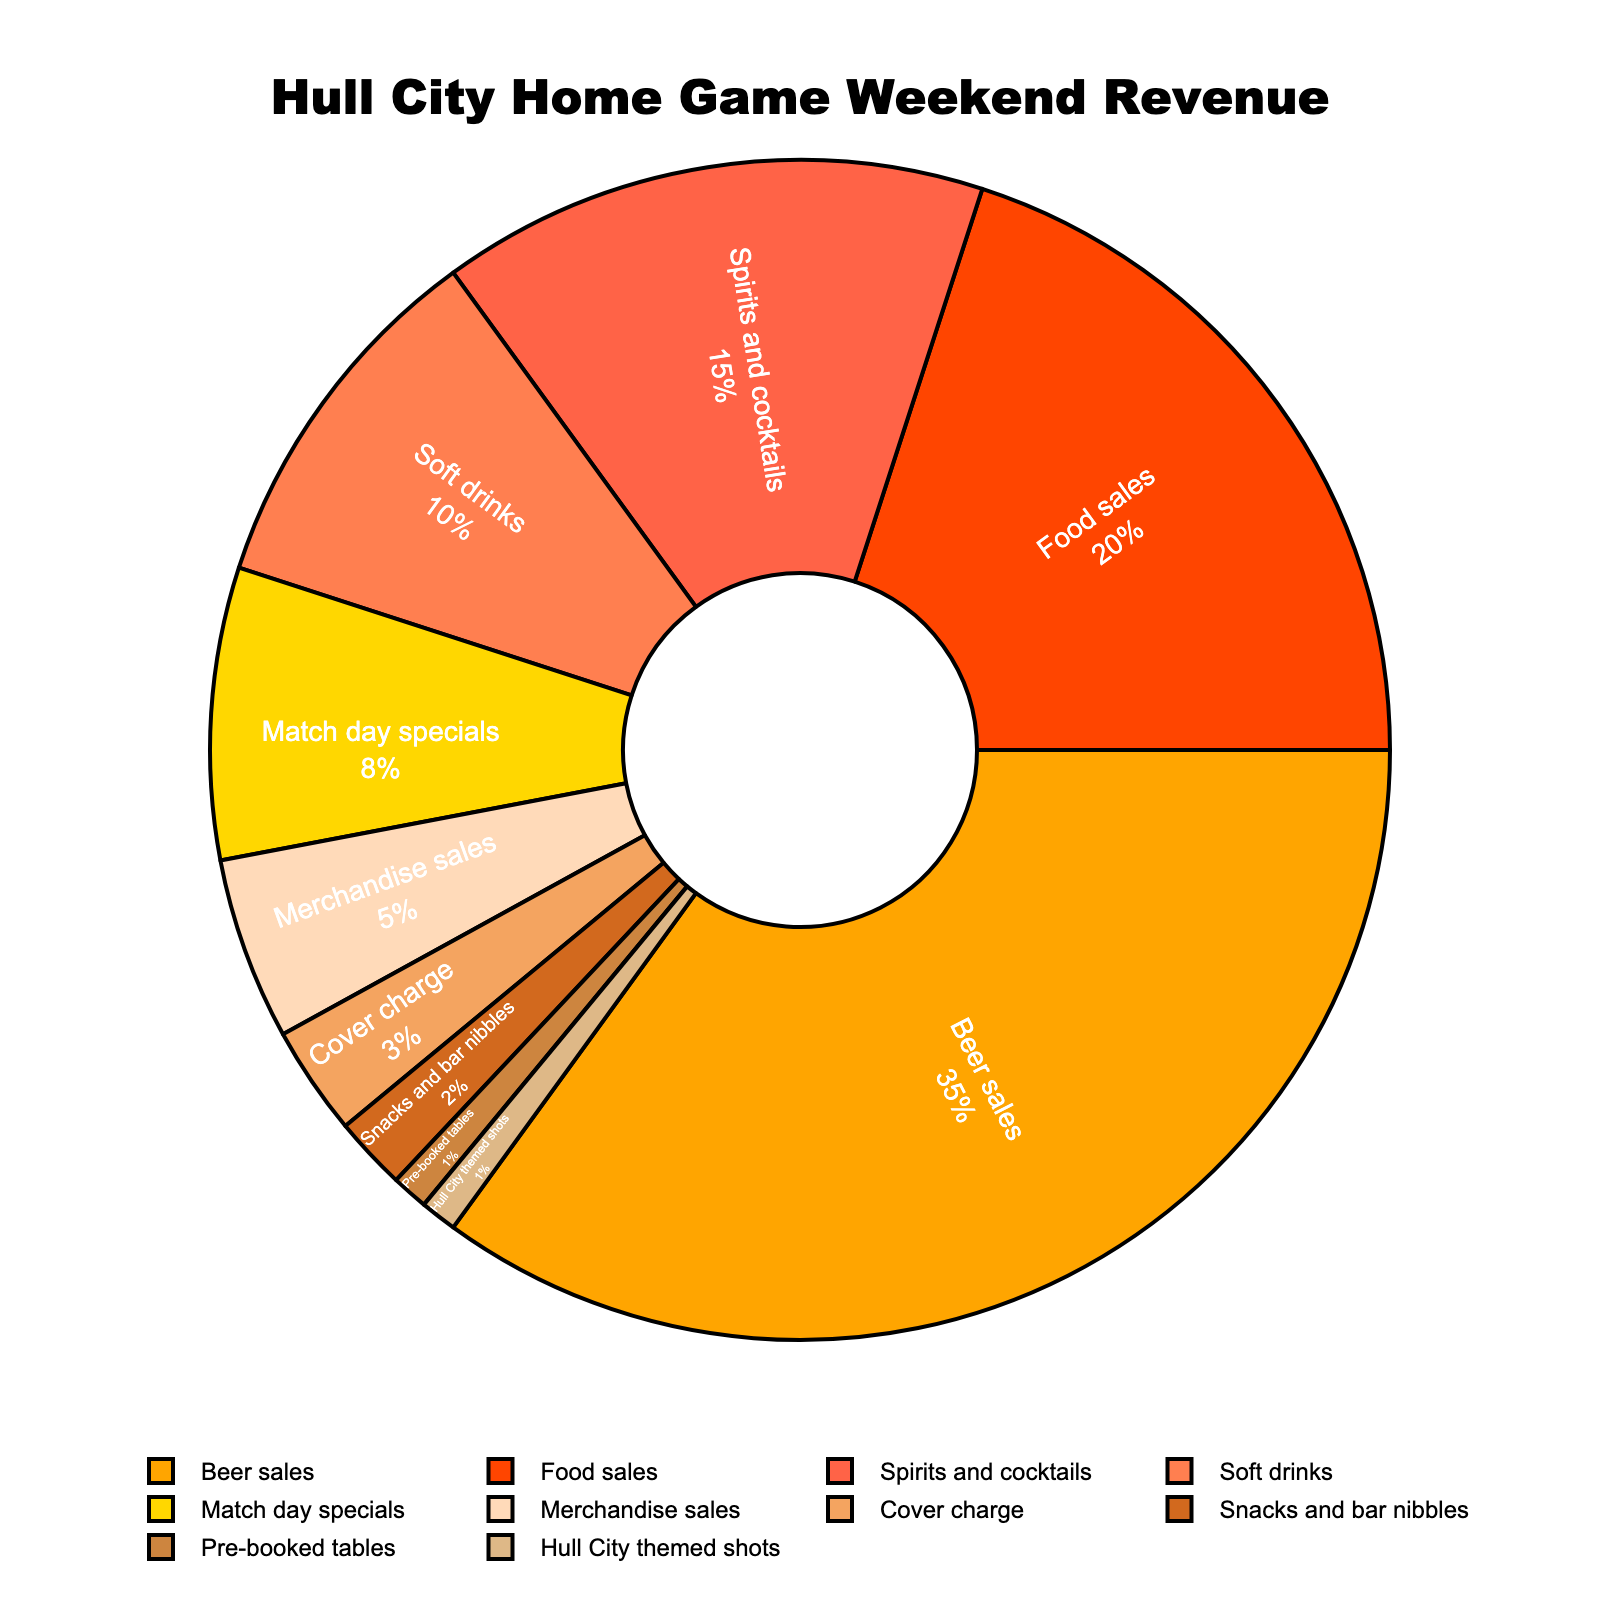Which category contributes the highest percentage to the pub's revenue during Hull City home game weekends? The figure shows a pie chart with different categories and their percentages. The largest segment is labeled "Beer sales" with 35%.
Answer: Beer sales What is the combined percentage of revenue from spirits and cocktails and soft drinks? Add the percentages of "Spirits and cocktails" (15%) and "Soft drinks" (10%). 15% + 10% = 25%.
Answer: 25% How much more does beer sales contribute to the revenue compared to food sales? Subtract the percentage of "Food sales" (20%) from "Beer sales" (35%). 35% - 20% = 15%.
Answer: 15% Which categories together contribute to less than 10% of the total revenue? Sum the percentages of categories less than 10%. Cover charge (3%), Snacks and bar nibbles (2%), pre-booked tables (1%), Hull City themed shots (1%) give a combined percentage of 7%.
Answer: Cover charge, Snacks and bar nibbles, Pre-booked tables, Hull City themed shots Is the revenue from merchandise sales greater than the revenue from match day specials? Compare the percentages. Merchandise sales (5%) is not greater than Match day specials (8%).
Answer: No What is the difference between the highest and the lowest percentage categories? The highest percentage is "Beer sales" (35%) and the lowest is tied among "Pre-booked tables" and "Hull City themed shots" (1%). The difference is 35% - 1% = 34%.
Answer: 34% Which visual colors appear in the largest segment of the pie chart? The largest segment, representing "Beer sales", is colored orange.
Answer: Orange How much more does food sales contribute compared to the combined percentage of Hull City themed shots and pre-booked tables? Food sales contribute 20%, Hull City themed shots and pre-booked tables each contribute 1%. Combined, that's 1% + 1% = 2%. The difference is 20% - 2% = 18%.
Answer: 18% What is the percentage of snacks and bar nibbles revenue relative to merchandise sales revenue? Calculate (Snacks and bar nibbles percentage / Merchandise sales percentage) * 100. (2% / 5%) * 100 = 40%.
Answer: 40% Is soft drinks revenue greater than the combined revenue of pre-booked tables and Hull City themed shots? Soft drinks is 10%, combined revenue of pre-booked tables and Hull City themed shots is 1% + 1% = 2%. 10% is greater than 2%.
Answer: Yes 